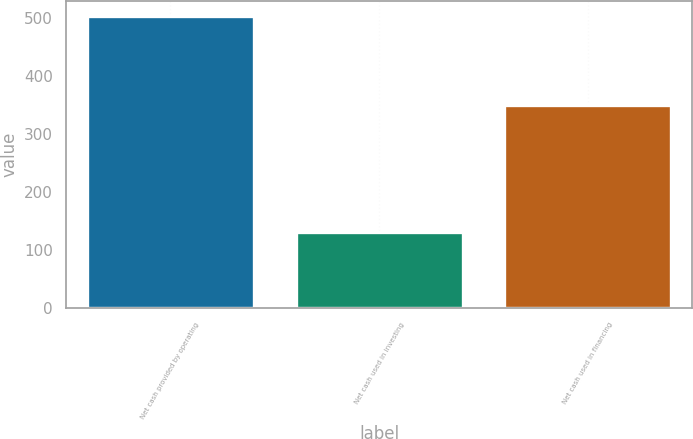Convert chart. <chart><loc_0><loc_0><loc_500><loc_500><bar_chart><fcel>Net cash provided by operating<fcel>Net cash used in investing<fcel>Net cash used in financing<nl><fcel>503.6<fcel>131.6<fcel>348.9<nl></chart> 